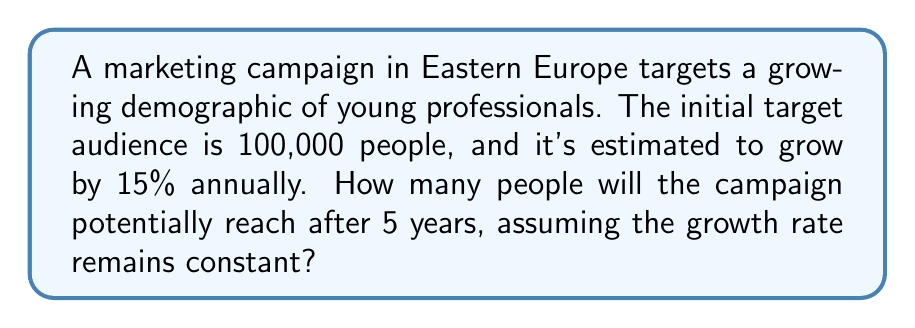Can you answer this question? To solve this problem, we'll use a geometric sequence, where the common ratio is 1.15 (representing 15% growth).

Let $a_n$ be the population in year $n$, where $a_0 = 100,000$ (initial population).
The common ratio $r = 1.15$ (15% growth = 1 + 0.15)

The formula for the nth term of a geometric sequence is:

$$a_n = a_0 \cdot r^n$$

For the 5th year (n = 5):

$$a_5 = 100,000 \cdot (1.15)^5$$

Now, let's calculate:

$$\begin{align}
a_5 &= 100,000 \cdot (1.15)^5 \\
&= 100,000 \cdot 2.0113689 \\
&= 201,136.89
\end{align}$$

Rounding to the nearest whole number, as we're dealing with people:

$$a_5 \approx 201,137$$
Answer: 201,137 people 